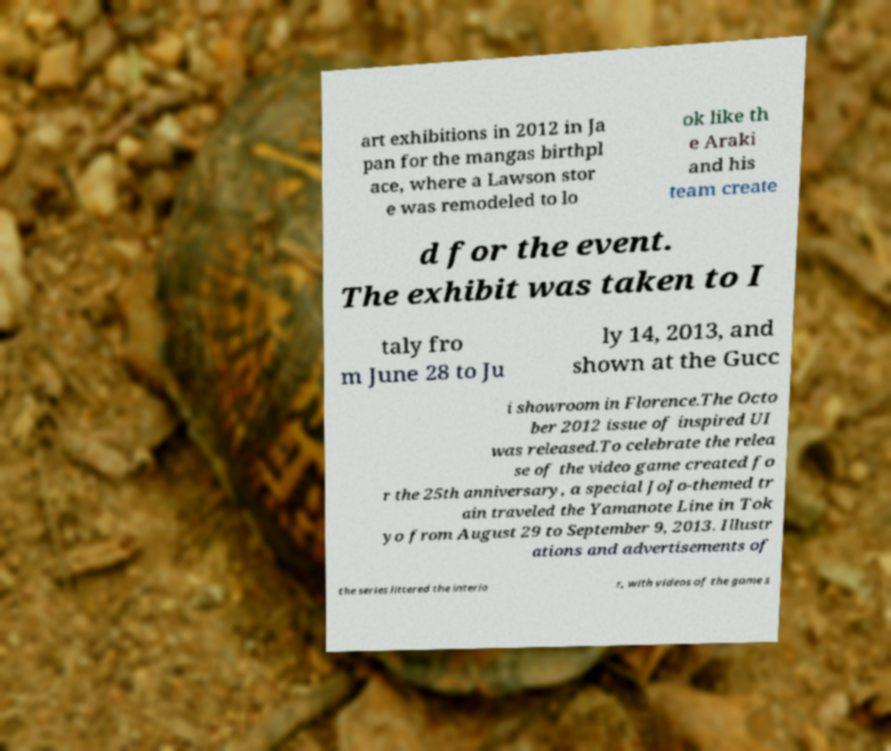Can you accurately transcribe the text from the provided image for me? art exhibitions in 2012 in Ja pan for the mangas birthpl ace, where a Lawson stor e was remodeled to lo ok like th e Araki and his team create d for the event. The exhibit was taken to I taly fro m June 28 to Ju ly 14, 2013, and shown at the Gucc i showroom in Florence.The Octo ber 2012 issue of inspired UI was released.To celebrate the relea se of the video game created fo r the 25th anniversary, a special JoJo-themed tr ain traveled the Yamanote Line in Tok yo from August 29 to September 9, 2013. Illustr ations and advertisements of the series littered the interio r, with videos of the game s 